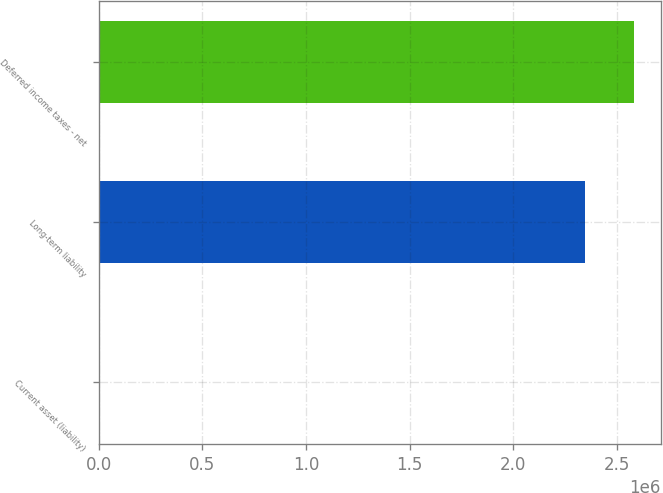Convert chart. <chart><loc_0><loc_0><loc_500><loc_500><bar_chart><fcel>Current asset (liability)<fcel>Long-term liability<fcel>Deferred income taxes - net<nl><fcel>2033<fcel>2.34772e+06<fcel>2.5825e+06<nl></chart> 